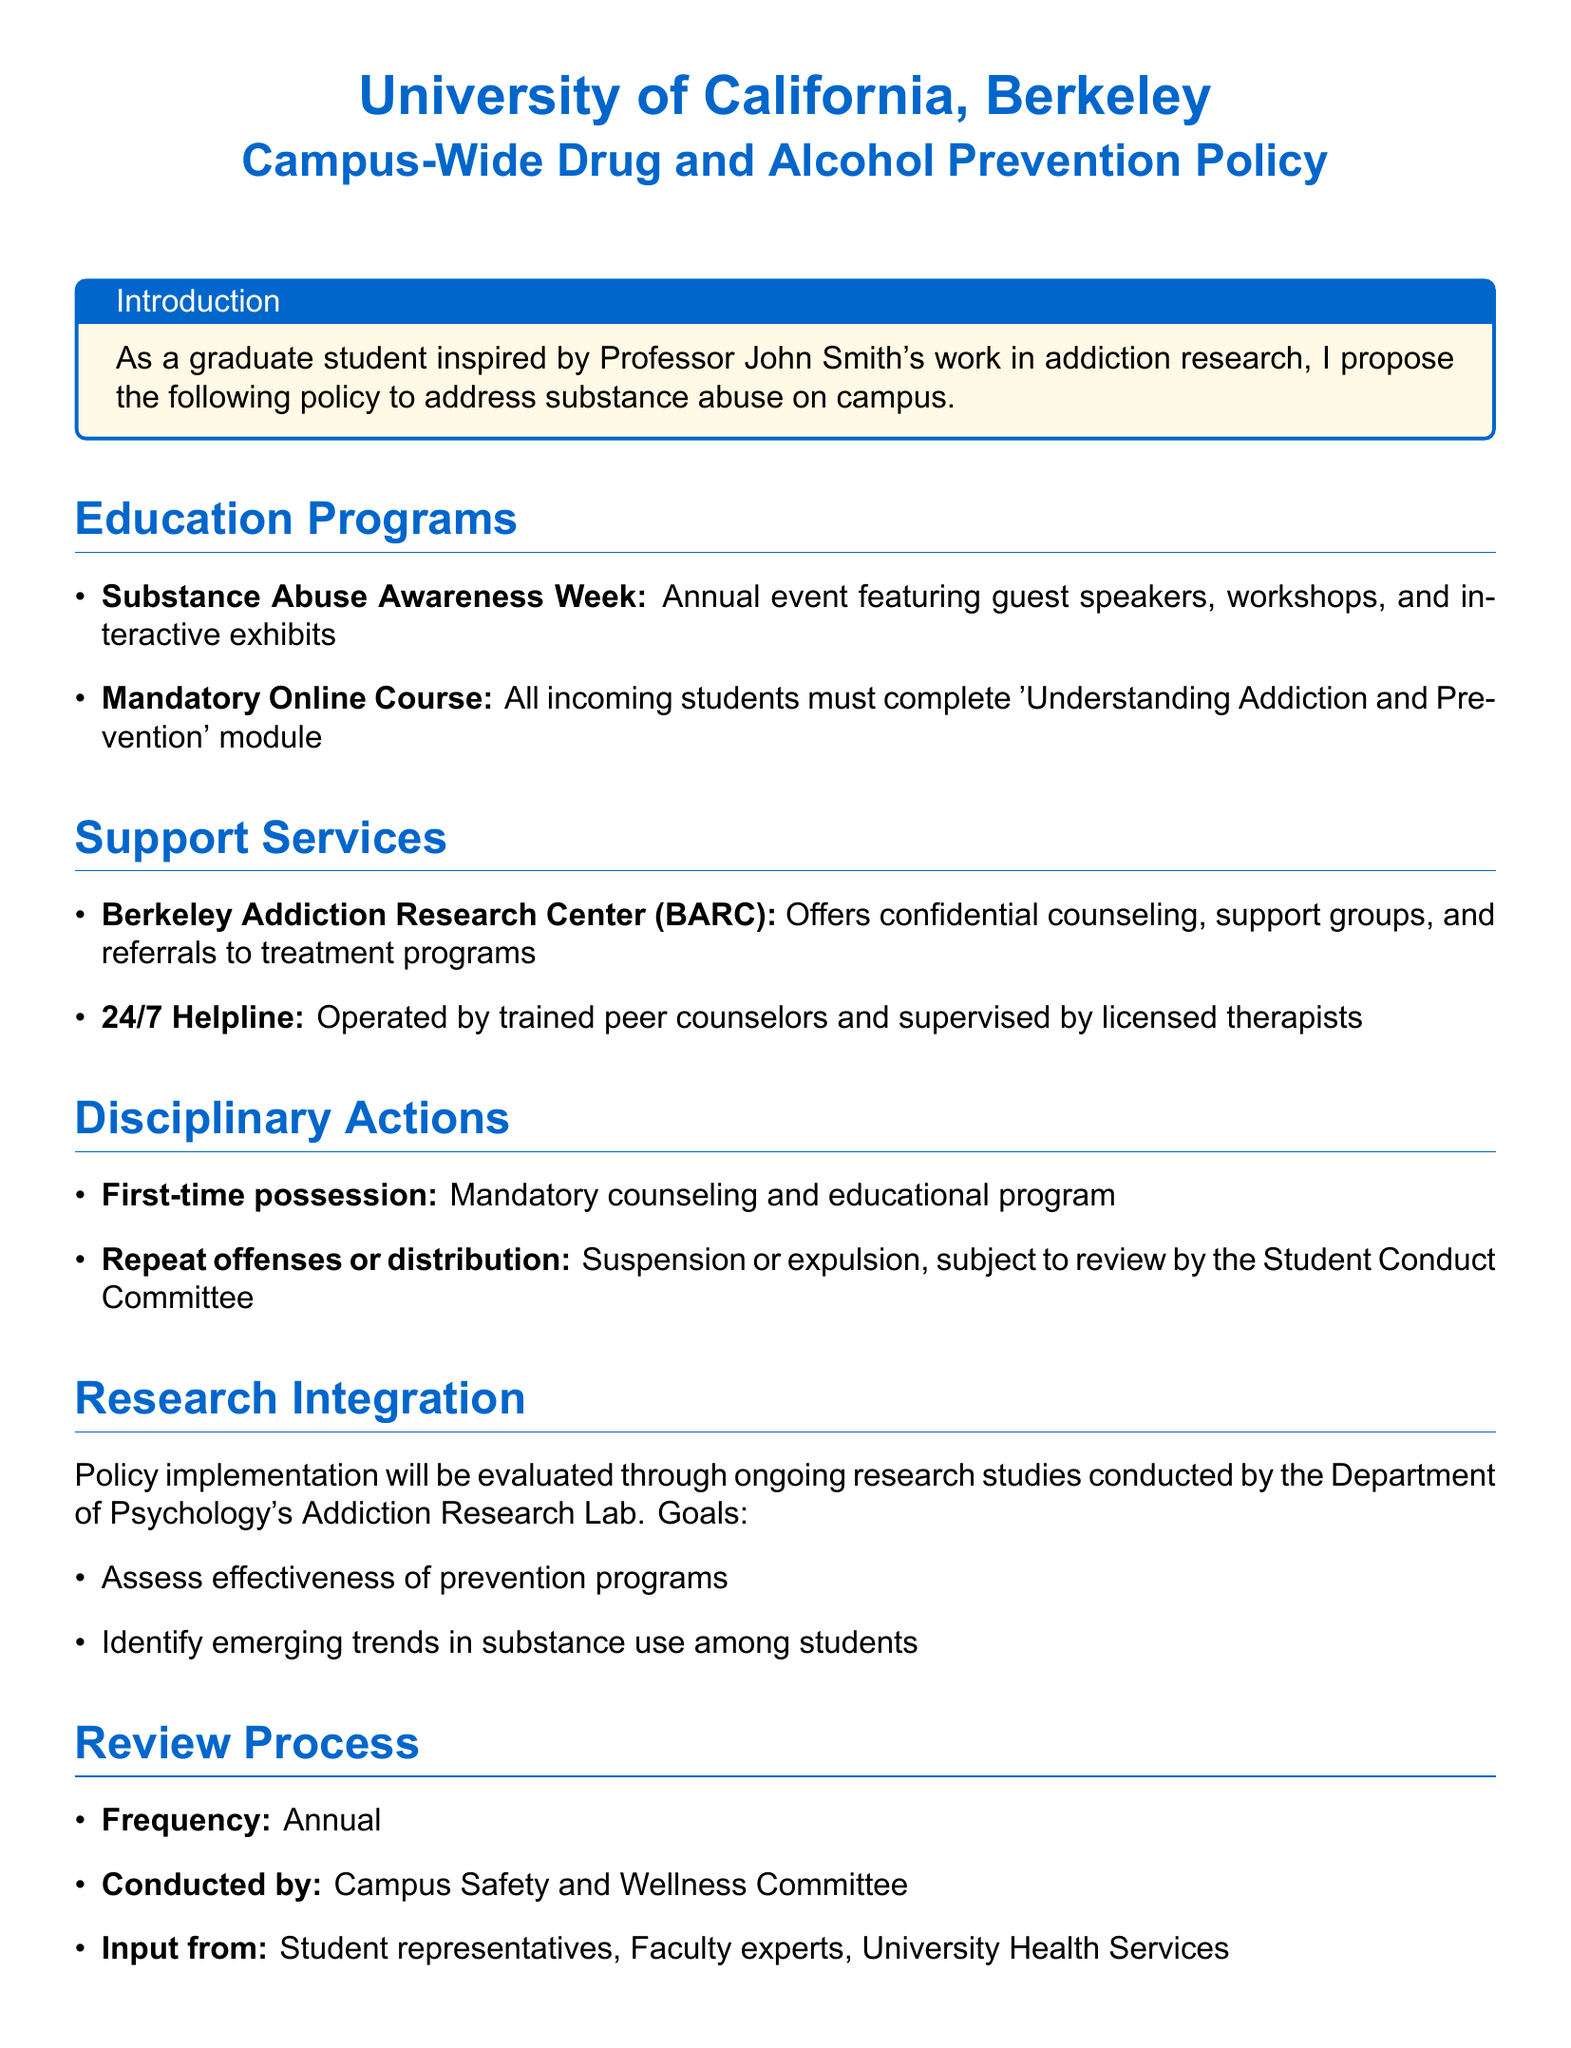What is the title of the policy document? The title of the document is provided in the heading at the top of the document.
Answer: Campus-Wide Drug and Alcohol Prevention Policy What is the name of the center that offers confidential counseling? The center is specifically mentioned in the Support Services section of the document.
Answer: Berkeley Addiction Research Center (BARC) What educational event occurs annually to raise substance abuse awareness? The event is outlined in the Education Programs section, indicating its purpose and frequency.
Answer: Substance Abuse Awareness Week What must all incoming students complete? This requirement is stated in the Education Programs section and emphasizes the importance of education on addiction.
Answer: Mandatory Online Course What is the consequence for a first-time possession? This discipline for first-time offenders is detailed in the Disciplinary Actions section of the document.
Answer: Mandatory counseling and educational program Who conducts the policy review? The document specifies which committee is responsible for reviewing the policy on an annual basis.
Answer: Campus Safety and Wellness Committee What is one goal of the ongoing research studies? This goal is provided in the Research Integration section, showcasing the focus of the studies concerning the effectiveness of the policy.
Answer: Assess effectiveness of prevention programs What type of support is available 24/7? The document mentions a specific service that provides constant support to students needing help.
Answer: Helpline What is the status for repeat offenses? This refers to the disciplinary measures taken for multiple infractions, as stated in the Disciplinary Actions section.
Answer: Suspension or expulsion 